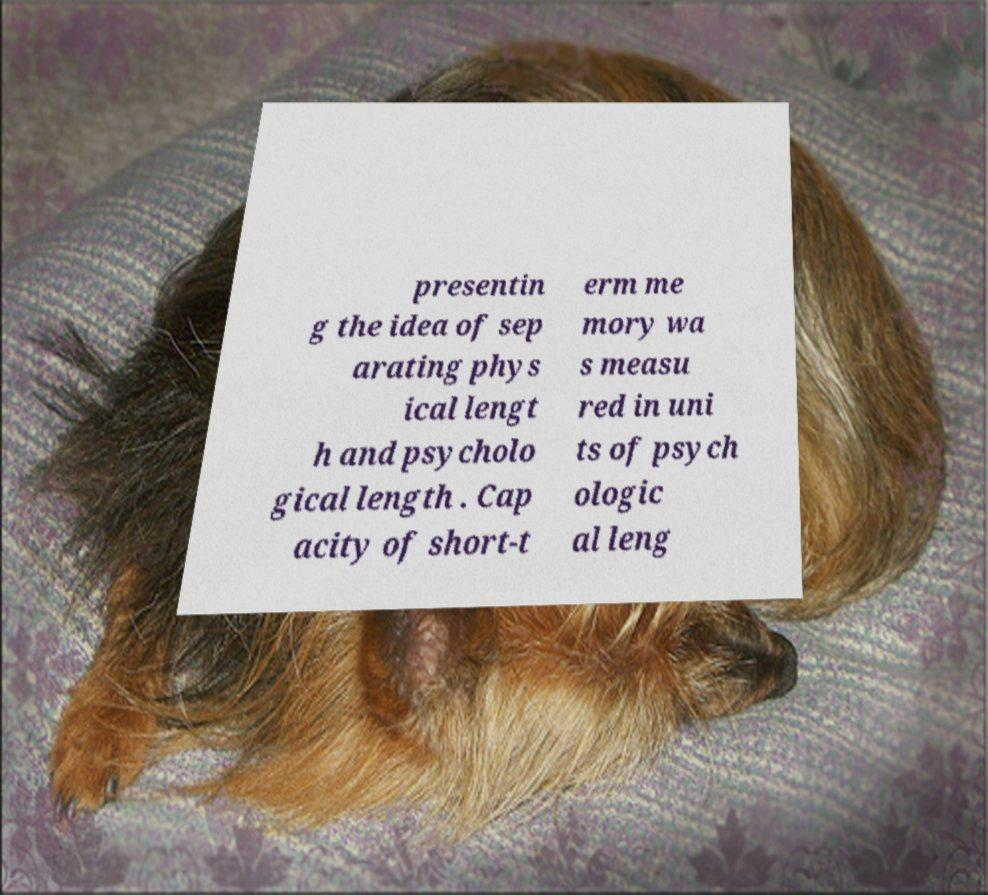Can you accurately transcribe the text from the provided image for me? presentin g the idea of sep arating phys ical lengt h and psycholo gical length . Cap acity of short-t erm me mory wa s measu red in uni ts of psych ologic al leng 